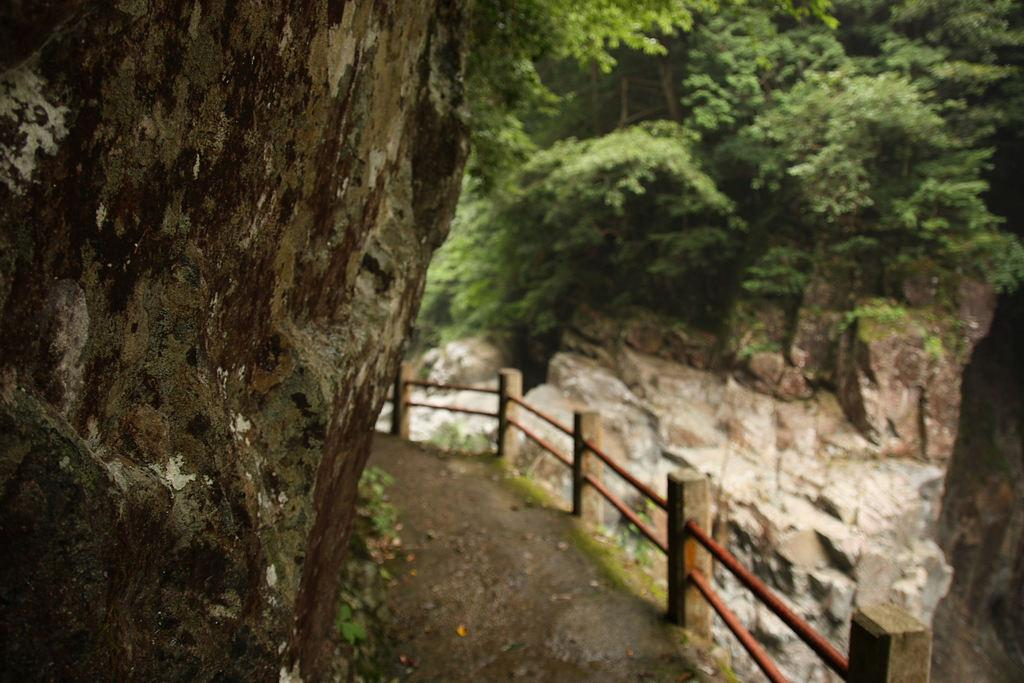What is the main subject in the center of the image? There is a tree in the center of the image. What can be seen on the right side of the image? There is fencing on the right side of the image. What is visible in the background of the image? There is a hill and trees in the background of the image. What story is your aunt telling in the image? There is no person or conversation depicted in the image, so it is not possible to answer a question about an aunt telling a story. 